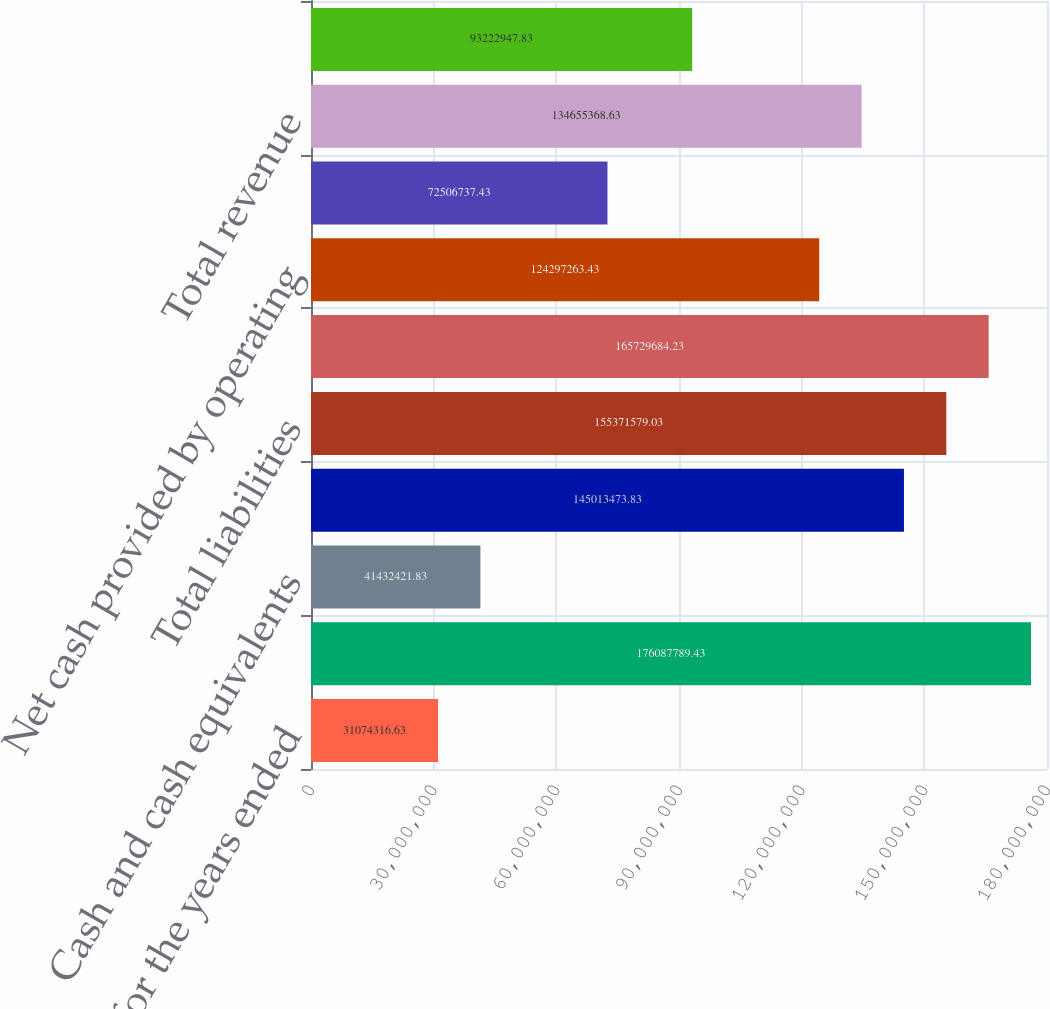Convert chart to OTSL. <chart><loc_0><loc_0><loc_500><loc_500><bar_chart><fcel>As of or for the years ended<fcel>Total assets (book value)<fcel>Cash and cash equivalents<fcel>Lines of credit and notes<fcel>Total liabilities<fcel>Total stockholders' equity<fcel>Net cash provided by operating<fcel>Net change in cash and cash<fcel>Total revenue<fcel>Income from continuing<nl><fcel>3.10743e+07<fcel>1.76088e+08<fcel>4.14324e+07<fcel>1.45013e+08<fcel>1.55372e+08<fcel>1.6573e+08<fcel>1.24297e+08<fcel>7.25067e+07<fcel>1.34655e+08<fcel>9.32229e+07<nl></chart> 